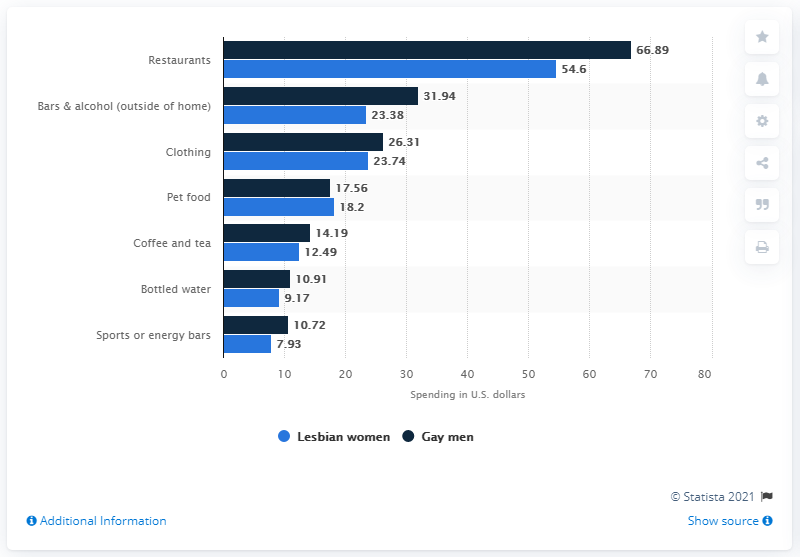Point out several critical features in this image. The average of the three largest numbers in the blue bar is 33.91. According to the data, gay men on average spent approximately $66.89 per week on restaurants. There are two bars that are located below the value of 10. 